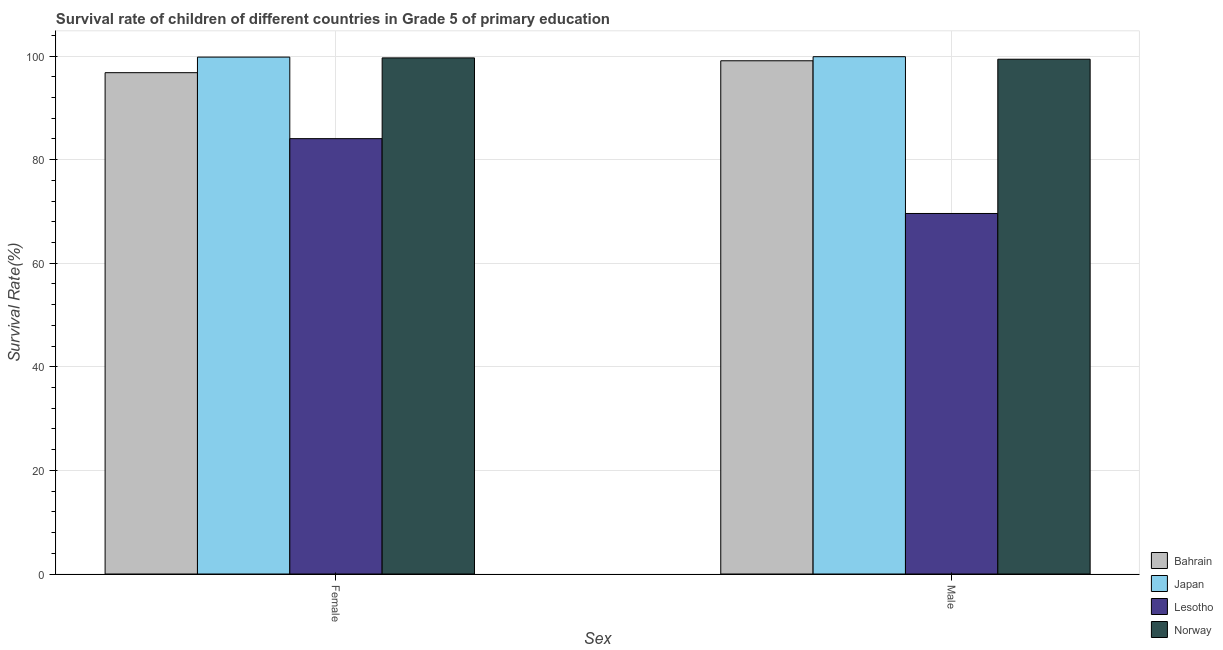How many bars are there on the 1st tick from the right?
Give a very brief answer. 4. What is the label of the 2nd group of bars from the left?
Provide a succinct answer. Male. What is the survival rate of female students in primary education in Norway?
Your answer should be very brief. 99.65. Across all countries, what is the maximum survival rate of female students in primary education?
Your answer should be compact. 99.81. Across all countries, what is the minimum survival rate of male students in primary education?
Offer a terse response. 69.61. In which country was the survival rate of female students in primary education maximum?
Your response must be concise. Japan. In which country was the survival rate of male students in primary education minimum?
Keep it short and to the point. Lesotho. What is the total survival rate of male students in primary education in the graph?
Your response must be concise. 367.99. What is the difference between the survival rate of female students in primary education in Norway and that in Lesotho?
Make the answer very short. 15.59. What is the difference between the survival rate of male students in primary education in Bahrain and the survival rate of female students in primary education in Lesotho?
Your answer should be very brief. 15.04. What is the average survival rate of male students in primary education per country?
Your response must be concise. 92. What is the difference between the survival rate of female students in primary education and survival rate of male students in primary education in Lesotho?
Make the answer very short. 14.45. In how many countries, is the survival rate of female students in primary education greater than 20 %?
Ensure brevity in your answer.  4. What is the ratio of the survival rate of male students in primary education in Bahrain to that in Japan?
Offer a terse response. 0.99. How many bars are there?
Ensure brevity in your answer.  8. What is the difference between two consecutive major ticks on the Y-axis?
Your response must be concise. 20. Are the values on the major ticks of Y-axis written in scientific E-notation?
Provide a succinct answer. No. Does the graph contain grids?
Your response must be concise. Yes. Where does the legend appear in the graph?
Give a very brief answer. Bottom right. How many legend labels are there?
Offer a terse response. 4. How are the legend labels stacked?
Ensure brevity in your answer.  Vertical. What is the title of the graph?
Offer a very short reply. Survival rate of children of different countries in Grade 5 of primary education. What is the label or title of the X-axis?
Make the answer very short. Sex. What is the label or title of the Y-axis?
Give a very brief answer. Survival Rate(%). What is the Survival Rate(%) in Bahrain in Female?
Ensure brevity in your answer.  96.8. What is the Survival Rate(%) of Japan in Female?
Your response must be concise. 99.81. What is the Survival Rate(%) in Lesotho in Female?
Give a very brief answer. 84.06. What is the Survival Rate(%) in Norway in Female?
Provide a succinct answer. 99.65. What is the Survival Rate(%) of Bahrain in Male?
Keep it short and to the point. 99.1. What is the Survival Rate(%) of Japan in Male?
Offer a very short reply. 99.88. What is the Survival Rate(%) in Lesotho in Male?
Provide a short and direct response. 69.61. What is the Survival Rate(%) in Norway in Male?
Make the answer very short. 99.39. Across all Sex, what is the maximum Survival Rate(%) in Bahrain?
Your response must be concise. 99.1. Across all Sex, what is the maximum Survival Rate(%) of Japan?
Keep it short and to the point. 99.88. Across all Sex, what is the maximum Survival Rate(%) in Lesotho?
Offer a very short reply. 84.06. Across all Sex, what is the maximum Survival Rate(%) of Norway?
Your answer should be very brief. 99.65. Across all Sex, what is the minimum Survival Rate(%) of Bahrain?
Your answer should be compact. 96.8. Across all Sex, what is the minimum Survival Rate(%) in Japan?
Your answer should be very brief. 99.81. Across all Sex, what is the minimum Survival Rate(%) of Lesotho?
Provide a succinct answer. 69.61. Across all Sex, what is the minimum Survival Rate(%) of Norway?
Your answer should be very brief. 99.39. What is the total Survival Rate(%) of Bahrain in the graph?
Your response must be concise. 195.89. What is the total Survival Rate(%) in Japan in the graph?
Make the answer very short. 199.69. What is the total Survival Rate(%) of Lesotho in the graph?
Keep it short and to the point. 153.67. What is the total Survival Rate(%) in Norway in the graph?
Offer a terse response. 199.04. What is the difference between the Survival Rate(%) in Bahrain in Female and that in Male?
Offer a terse response. -2.3. What is the difference between the Survival Rate(%) of Japan in Female and that in Male?
Give a very brief answer. -0.08. What is the difference between the Survival Rate(%) of Lesotho in Female and that in Male?
Make the answer very short. 14.45. What is the difference between the Survival Rate(%) in Norway in Female and that in Male?
Your response must be concise. 0.26. What is the difference between the Survival Rate(%) of Bahrain in Female and the Survival Rate(%) of Japan in Male?
Provide a short and direct response. -3.09. What is the difference between the Survival Rate(%) in Bahrain in Female and the Survival Rate(%) in Lesotho in Male?
Provide a succinct answer. 27.18. What is the difference between the Survival Rate(%) of Bahrain in Female and the Survival Rate(%) of Norway in Male?
Your answer should be compact. -2.6. What is the difference between the Survival Rate(%) of Japan in Female and the Survival Rate(%) of Lesotho in Male?
Your response must be concise. 30.19. What is the difference between the Survival Rate(%) of Japan in Female and the Survival Rate(%) of Norway in Male?
Offer a very short reply. 0.41. What is the difference between the Survival Rate(%) of Lesotho in Female and the Survival Rate(%) of Norway in Male?
Provide a succinct answer. -15.33. What is the average Survival Rate(%) in Bahrain per Sex?
Ensure brevity in your answer.  97.95. What is the average Survival Rate(%) in Japan per Sex?
Make the answer very short. 99.84. What is the average Survival Rate(%) in Lesotho per Sex?
Make the answer very short. 76.84. What is the average Survival Rate(%) of Norway per Sex?
Offer a very short reply. 99.52. What is the difference between the Survival Rate(%) in Bahrain and Survival Rate(%) in Japan in Female?
Offer a terse response. -3.01. What is the difference between the Survival Rate(%) of Bahrain and Survival Rate(%) of Lesotho in Female?
Your answer should be very brief. 12.74. What is the difference between the Survival Rate(%) of Bahrain and Survival Rate(%) of Norway in Female?
Keep it short and to the point. -2.85. What is the difference between the Survival Rate(%) of Japan and Survival Rate(%) of Lesotho in Female?
Offer a very short reply. 15.75. What is the difference between the Survival Rate(%) in Japan and Survival Rate(%) in Norway in Female?
Make the answer very short. 0.15. What is the difference between the Survival Rate(%) in Lesotho and Survival Rate(%) in Norway in Female?
Offer a very short reply. -15.59. What is the difference between the Survival Rate(%) of Bahrain and Survival Rate(%) of Japan in Male?
Provide a succinct answer. -0.79. What is the difference between the Survival Rate(%) of Bahrain and Survival Rate(%) of Lesotho in Male?
Your answer should be compact. 29.48. What is the difference between the Survival Rate(%) in Bahrain and Survival Rate(%) in Norway in Male?
Ensure brevity in your answer.  -0.3. What is the difference between the Survival Rate(%) in Japan and Survival Rate(%) in Lesotho in Male?
Provide a short and direct response. 30.27. What is the difference between the Survival Rate(%) in Japan and Survival Rate(%) in Norway in Male?
Offer a very short reply. 0.49. What is the difference between the Survival Rate(%) of Lesotho and Survival Rate(%) of Norway in Male?
Make the answer very short. -29.78. What is the ratio of the Survival Rate(%) of Bahrain in Female to that in Male?
Give a very brief answer. 0.98. What is the ratio of the Survival Rate(%) in Lesotho in Female to that in Male?
Provide a short and direct response. 1.21. What is the ratio of the Survival Rate(%) in Norway in Female to that in Male?
Provide a succinct answer. 1. What is the difference between the highest and the second highest Survival Rate(%) in Bahrain?
Keep it short and to the point. 2.3. What is the difference between the highest and the second highest Survival Rate(%) in Japan?
Offer a terse response. 0.08. What is the difference between the highest and the second highest Survival Rate(%) in Lesotho?
Your answer should be very brief. 14.45. What is the difference between the highest and the second highest Survival Rate(%) in Norway?
Keep it short and to the point. 0.26. What is the difference between the highest and the lowest Survival Rate(%) in Bahrain?
Your answer should be compact. 2.3. What is the difference between the highest and the lowest Survival Rate(%) in Japan?
Your response must be concise. 0.08. What is the difference between the highest and the lowest Survival Rate(%) of Lesotho?
Offer a very short reply. 14.45. What is the difference between the highest and the lowest Survival Rate(%) of Norway?
Provide a succinct answer. 0.26. 